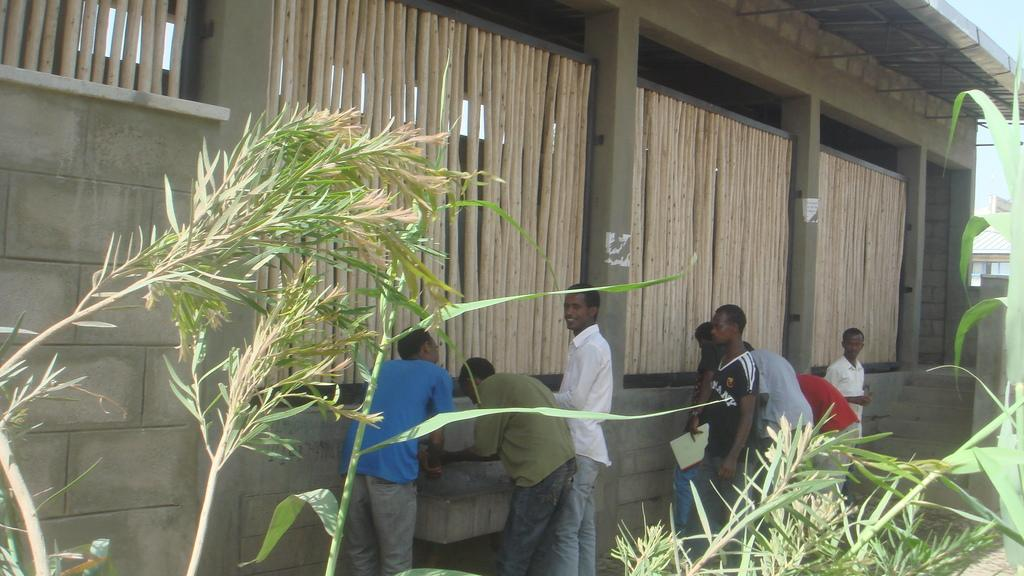What type of structure is visible in the image? There is a building in the image. What objects can be seen in addition to the building? There are wooden sticks and plants visible in the image. Are there any living beings in the image? Yes, there are people in the image. What type of advice can be seen written on the building in the image? There is no advice written on the building in the image. What type of attraction is present in the image? There is no specific attraction mentioned in the image; it simply shows a building, wooden sticks, people, and plants. 